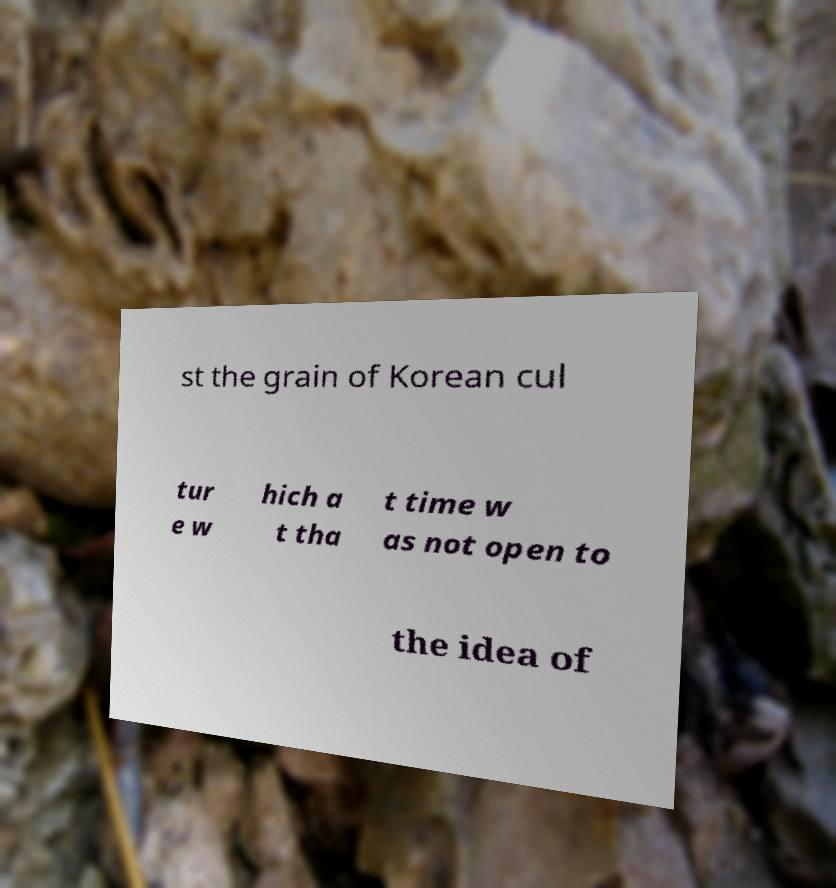Can you accurately transcribe the text from the provided image for me? st the grain of Korean cul tur e w hich a t tha t time w as not open to the idea of 